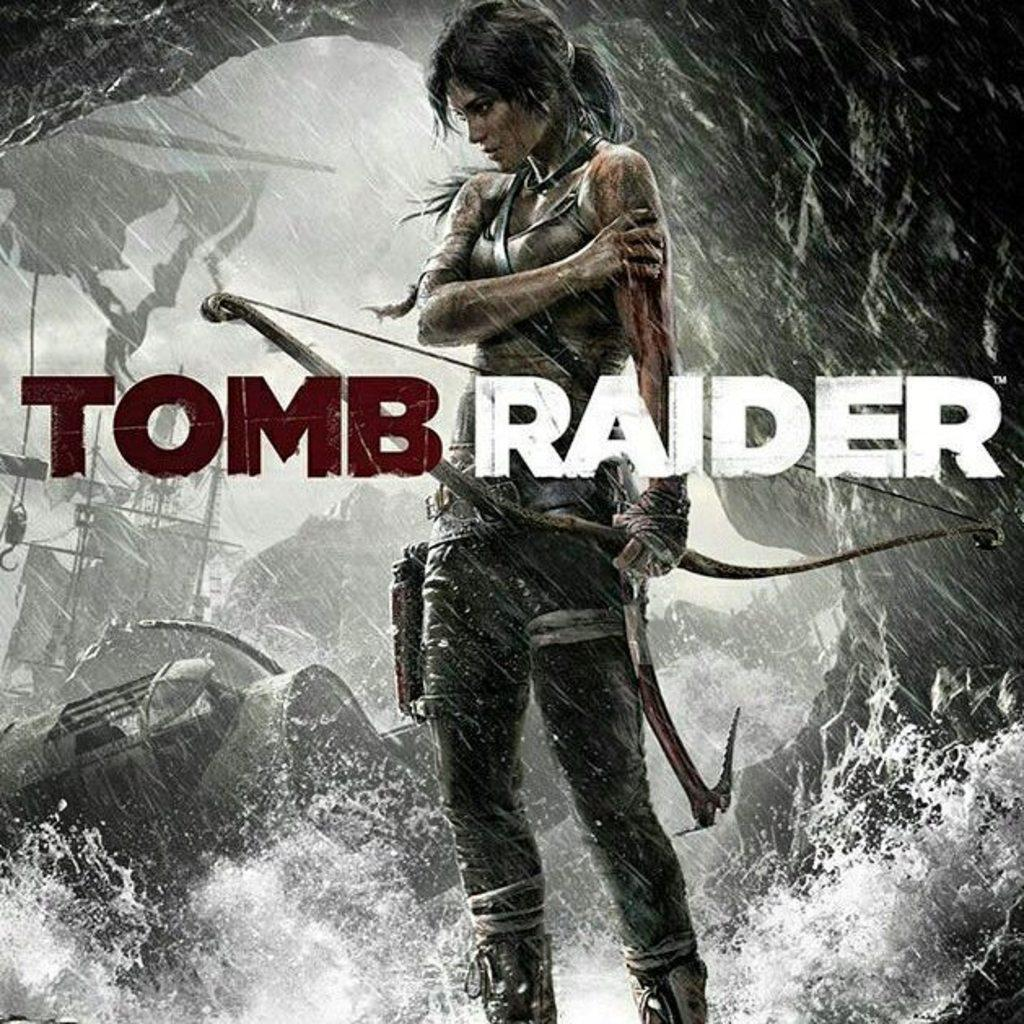<image>
Relay a brief, clear account of the picture shown. a game that is called Tomb Raider with a woman on it 